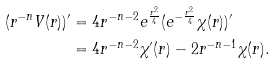Convert formula to latex. <formula><loc_0><loc_0><loc_500><loc_500>( r ^ { - n } V ( r ) ) ^ { \prime } & = 4 r ^ { - n - 2 } e ^ { \frac { r ^ { 2 } } 4 } ( e ^ { - \frac { r ^ { 2 } } 4 } \chi ( r ) ) ^ { \prime } \\ & = 4 r ^ { - n - 2 } \chi ^ { \prime } ( r ) - 2 r ^ { - n - 1 } \chi ( r ) .</formula> 